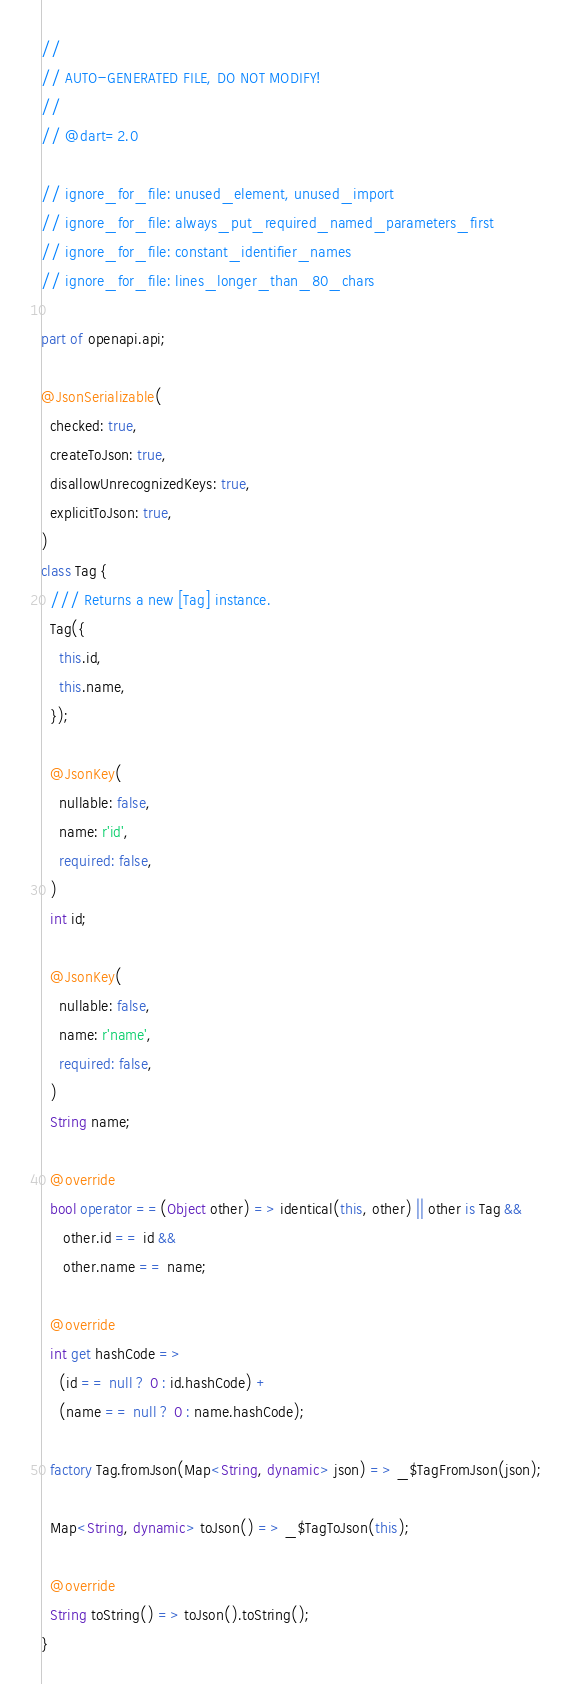Convert code to text. <code><loc_0><loc_0><loc_500><loc_500><_Dart_>//
// AUTO-GENERATED FILE, DO NOT MODIFY!
//
// @dart=2.0

// ignore_for_file: unused_element, unused_import
// ignore_for_file: always_put_required_named_parameters_first
// ignore_for_file: constant_identifier_names
// ignore_for_file: lines_longer_than_80_chars

part of openapi.api;

@JsonSerializable(
  checked: true,
  createToJson: true,
  disallowUnrecognizedKeys: true,
  explicitToJson: true,
)
class Tag {
  /// Returns a new [Tag] instance.
  Tag({
    this.id,
    this.name,
  });

  @JsonKey(
    nullable: false,
    name: r'id',
    required: false,
  )
  int id;

  @JsonKey(
    nullable: false,
    name: r'name',
    required: false,
  )
  String name;

  @override
  bool operator ==(Object other) => identical(this, other) || other is Tag &&
     other.id == id &&
     other.name == name;

  @override
  int get hashCode =>
    (id == null ? 0 : id.hashCode) +
    (name == null ? 0 : name.hashCode);

  factory Tag.fromJson(Map<String, dynamic> json) => _$TagFromJson(json);

  Map<String, dynamic> toJson() => _$TagToJson(this);

  @override
  String toString() => toJson().toString();
}

</code> 